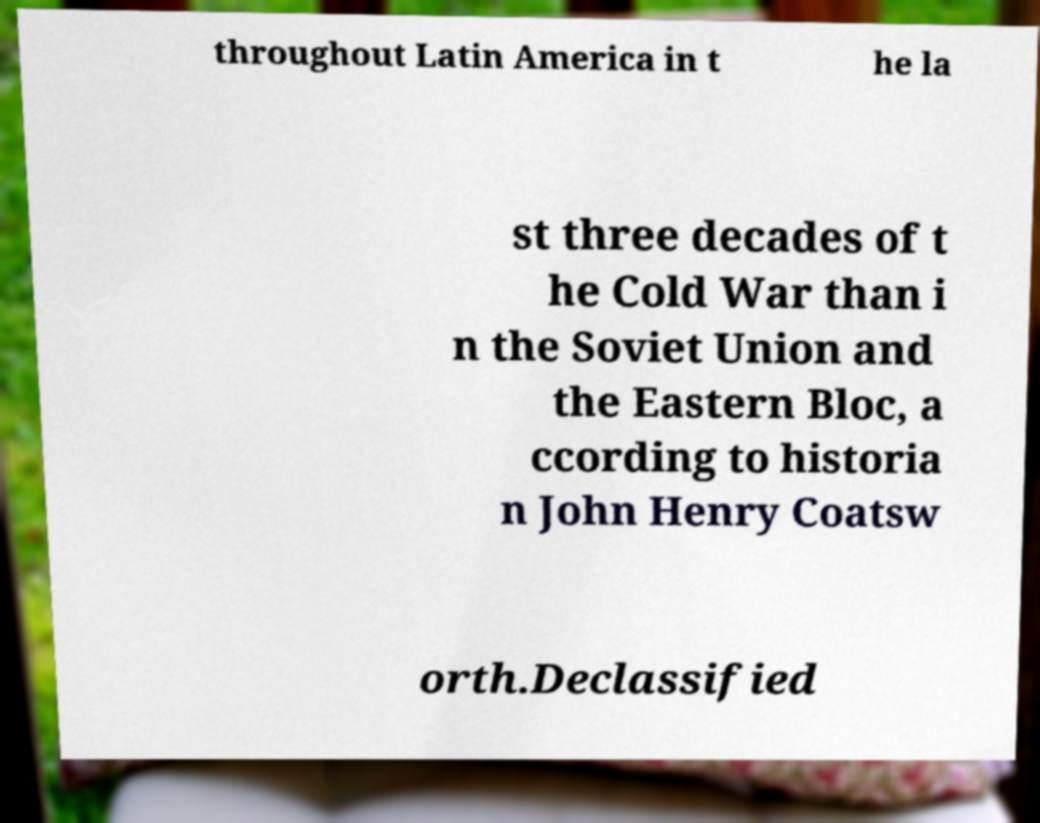For documentation purposes, I need the text within this image transcribed. Could you provide that? throughout Latin America in t he la st three decades of t he Cold War than i n the Soviet Union and the Eastern Bloc, a ccording to historia n John Henry Coatsw orth.Declassified 